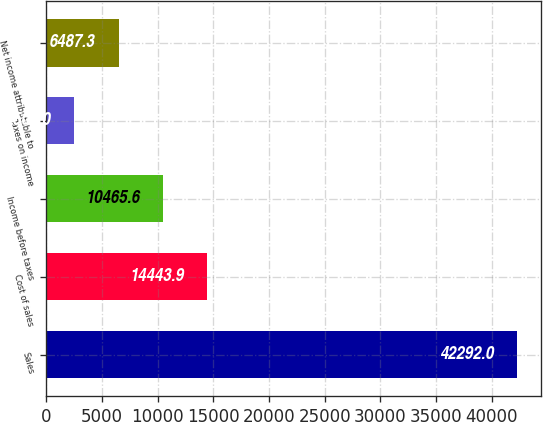<chart> <loc_0><loc_0><loc_500><loc_500><bar_chart><fcel>Sales<fcel>Cost of sales<fcel>Income before taxes<fcel>Taxes on income<fcel>Net income attributable to<nl><fcel>42292<fcel>14443.9<fcel>10465.6<fcel>2509<fcel>6487.3<nl></chart> 